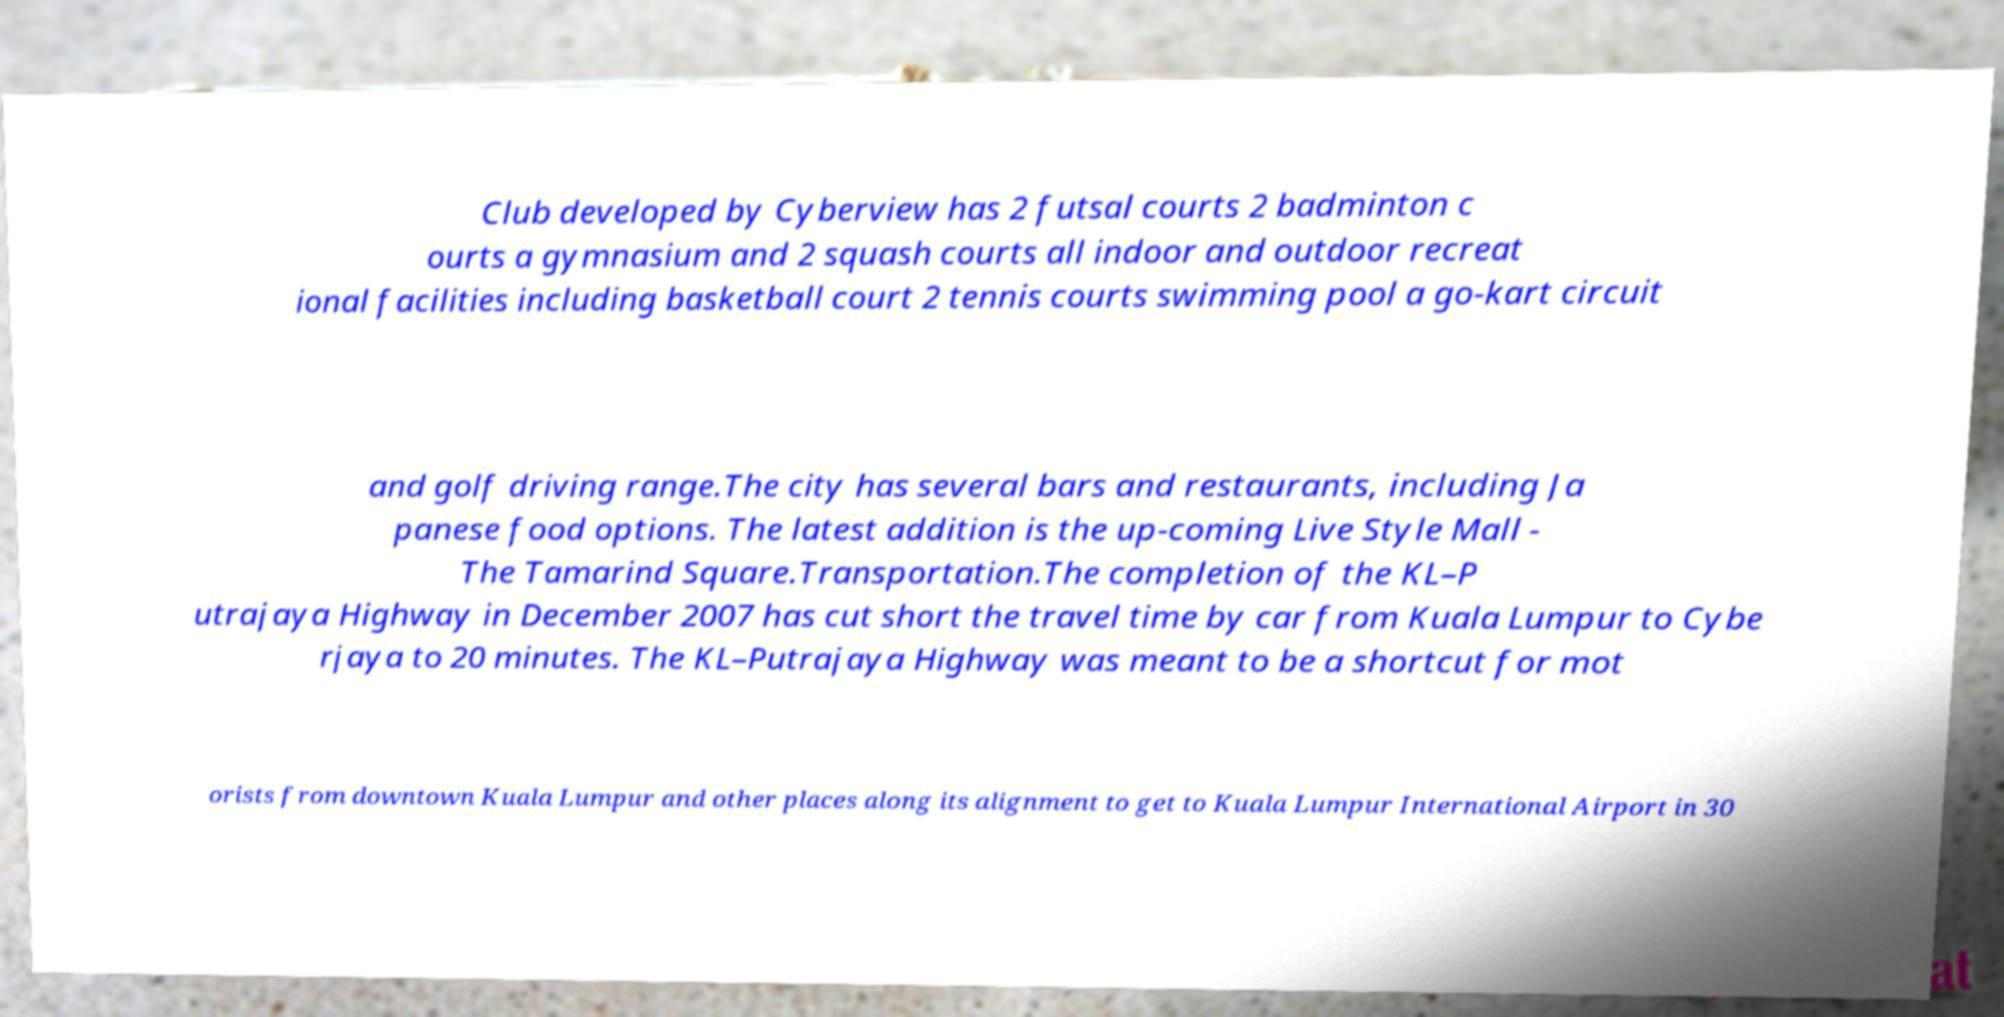Please identify and transcribe the text found in this image. Club developed by Cyberview has 2 futsal courts 2 badminton c ourts a gymnasium and 2 squash courts all indoor and outdoor recreat ional facilities including basketball court 2 tennis courts swimming pool a go-kart circuit and golf driving range.The city has several bars and restaurants, including Ja panese food options. The latest addition is the up-coming Live Style Mall - The Tamarind Square.Transportation.The completion of the KL–P utrajaya Highway in December 2007 has cut short the travel time by car from Kuala Lumpur to Cybe rjaya to 20 minutes. The KL–Putrajaya Highway was meant to be a shortcut for mot orists from downtown Kuala Lumpur and other places along its alignment to get to Kuala Lumpur International Airport in 30 